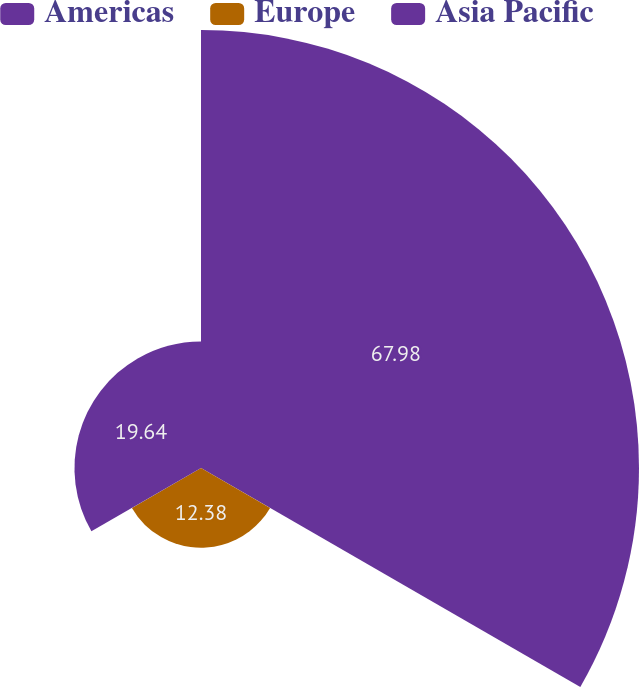Convert chart. <chart><loc_0><loc_0><loc_500><loc_500><pie_chart><fcel>Americas<fcel>Europe<fcel>Asia Pacific<nl><fcel>67.98%<fcel>12.38%<fcel>19.64%<nl></chart> 